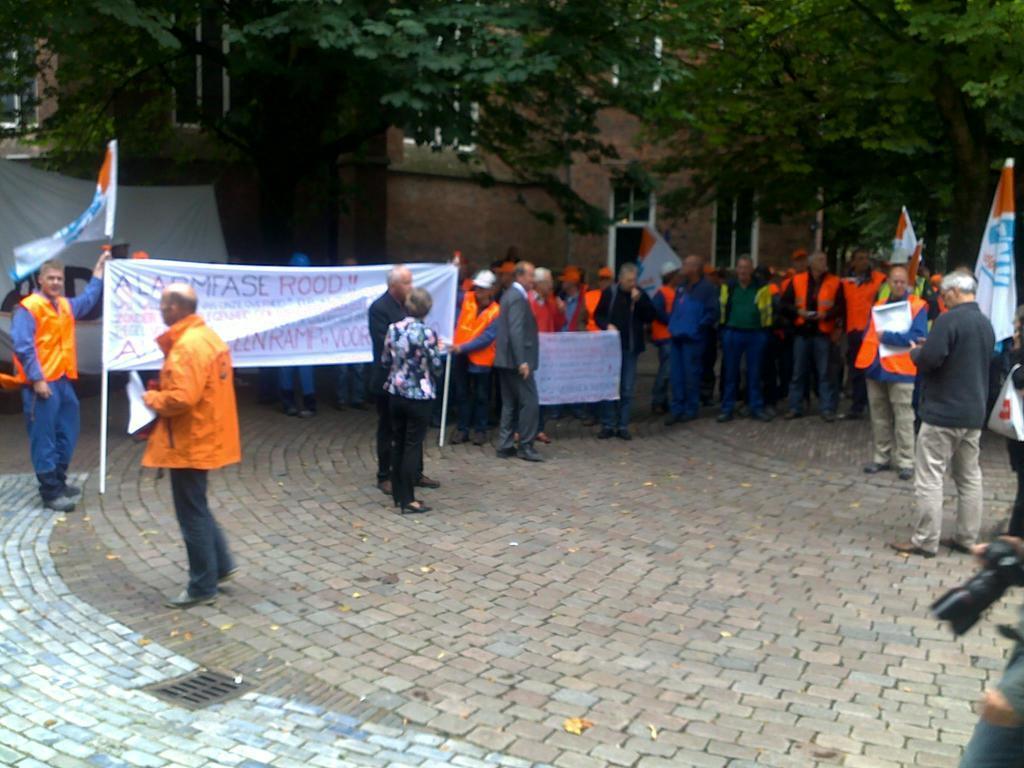Can you describe this image briefly? In this picture I can observe some people standing on the land. On the left side there are two members holding a flex. I can observe some trees and a building in the background. 